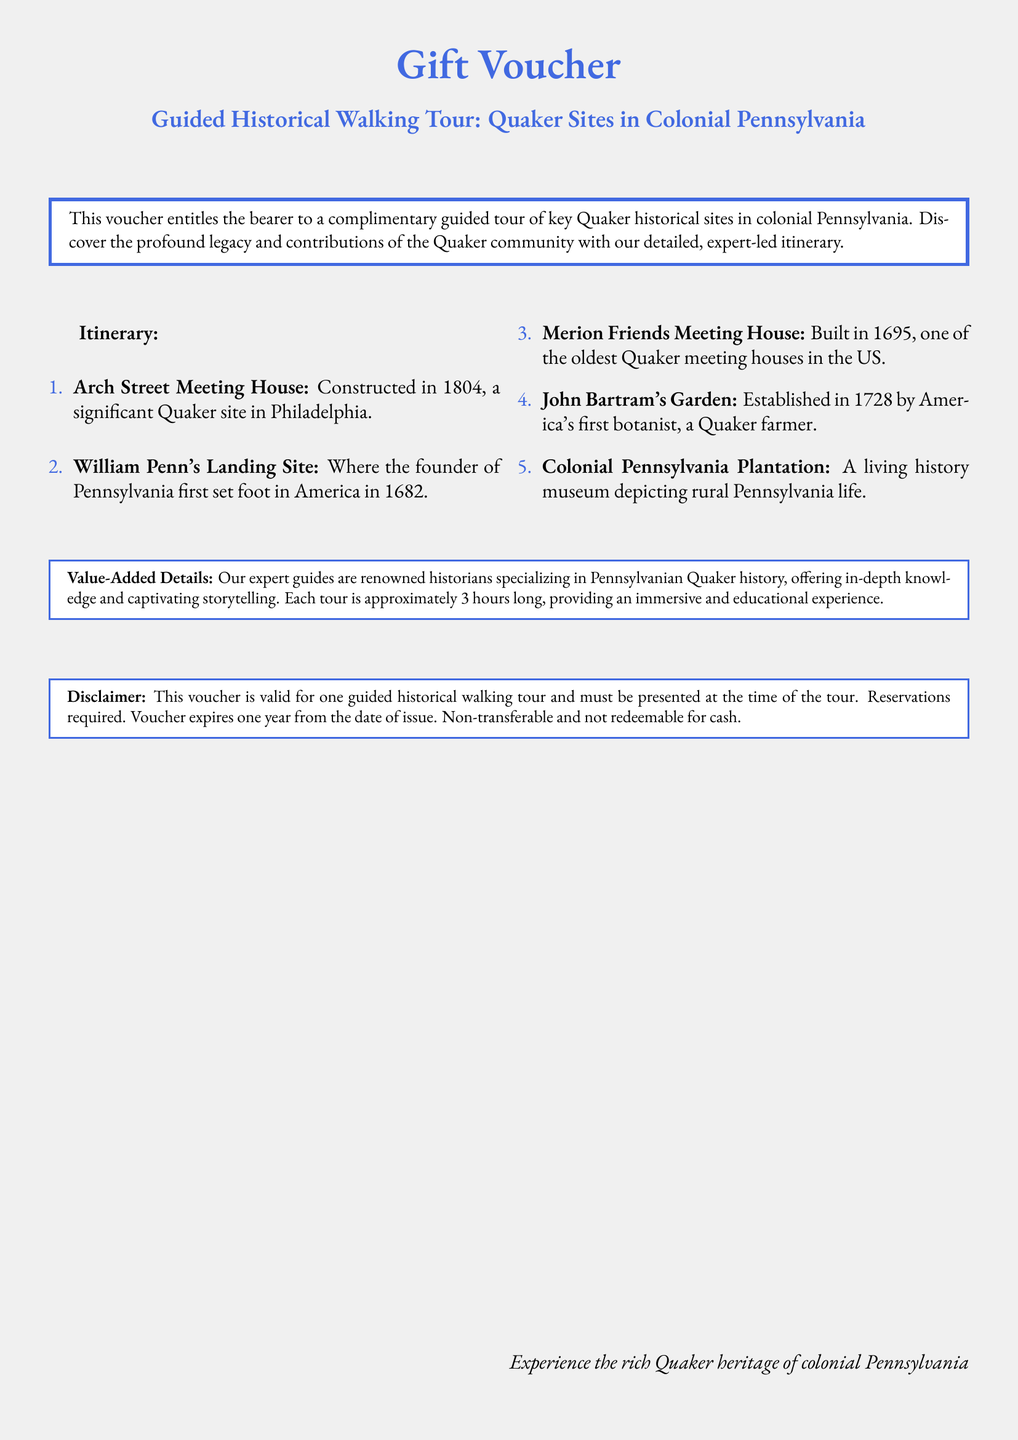What is the title of the voucher? The title of the voucher is explicitly presented in the document as the main header.
Answer: Guided Historical Walking Tour: Quaker Sites in Colonial Pennsylvania How many sites are included in the itinerary? The itinerary section lists the number of locations that are part of the guided tour.
Answer: 5 What year was the Arch Street Meeting House constructed? The construction year is mentioned next to the site description in the itinerary.
Answer: 1804 Who established John Bartram's Garden? The document states the contributor of the garden, highlighting their significance in a historical context.
Answer: America's first botanist What is the duration of the tour? The value-added details mention the length of the tour, providing insights into the experience.
Answer: Approximately 3 hours What is the validity period of the voucher? The disclaimer section clarifies how long the voucher remains usable from its issue date.
Answer: One year Which historical figure's landing site is included in the tour? The itinerary specifies the individual associated with the significant location on the tour.
Answer: William Penn Is the voucher transferable? The disclaimer explicitly states the terms regarding the transferability of the voucher.
Answer: Non-transferable 